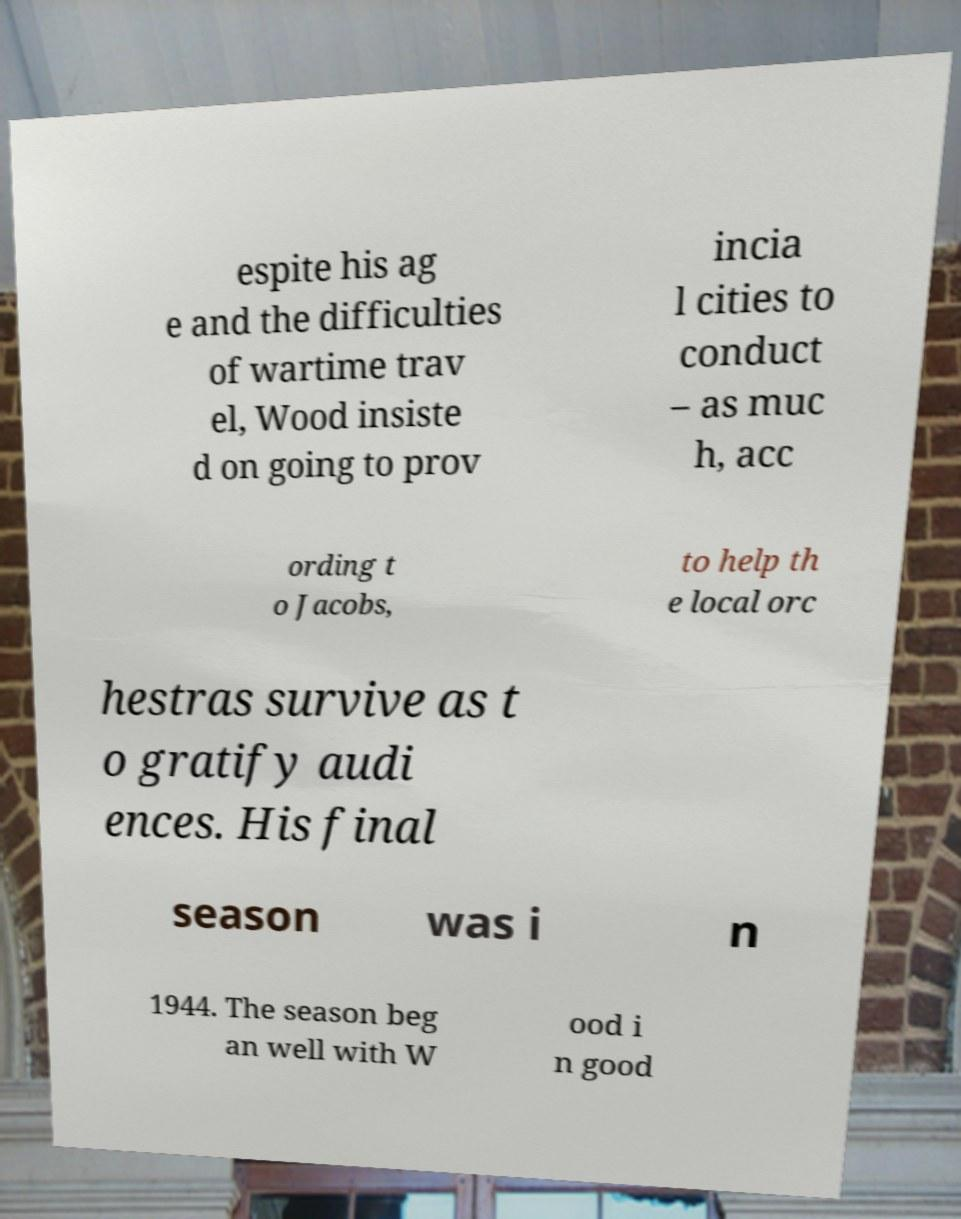Please identify and transcribe the text found in this image. espite his ag e and the difficulties of wartime trav el, Wood insiste d on going to prov incia l cities to conduct – as muc h, acc ording t o Jacobs, to help th e local orc hestras survive as t o gratify audi ences. His final season was i n 1944. The season beg an well with W ood i n good 